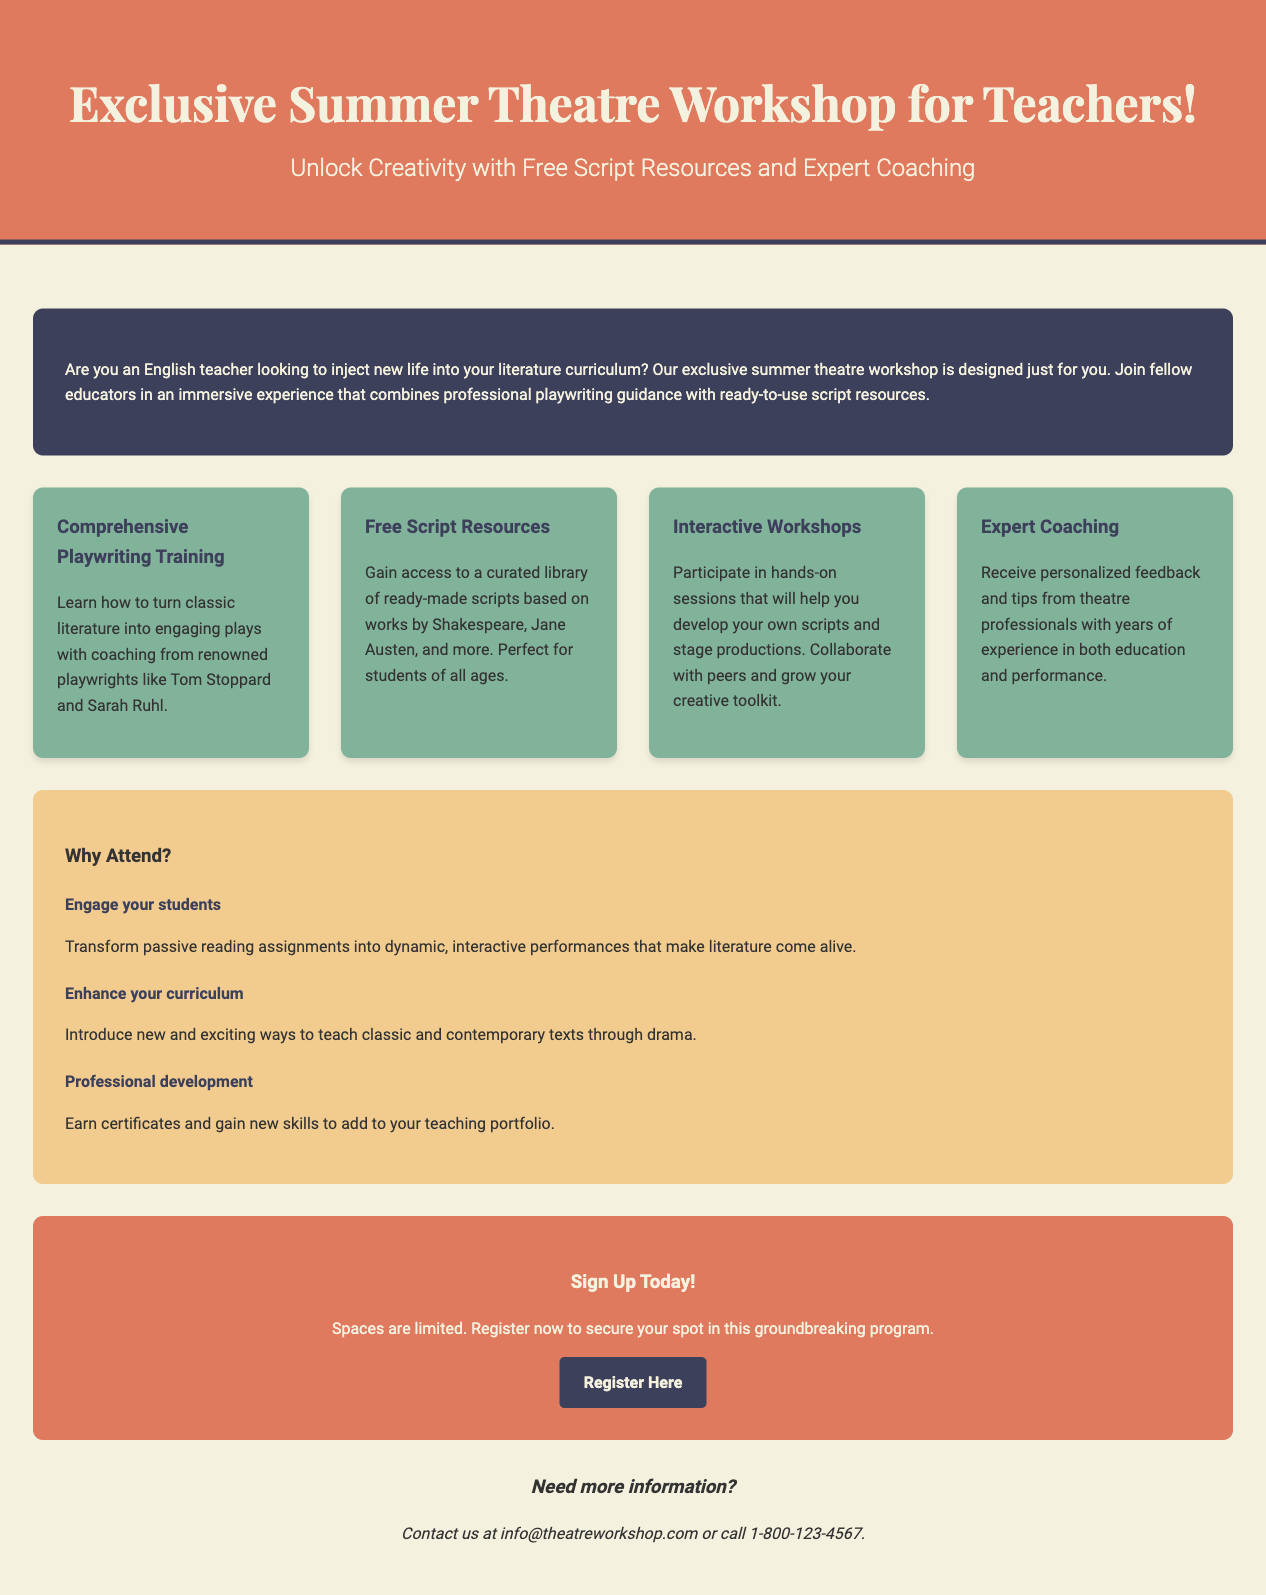What is the title of the workshop? The title of the workshop is clearly stated at the beginning of the document as "Exclusive Summer Theatre Workshop for Teachers!"
Answer: Exclusive Summer Theatre Workshop for Teachers! Who is the target audience for the workshop? The workshop is designed specifically for English teachers, as mentioned in the introduction.
Answer: English teachers What type of training is offered in the workshop? The document specifies that "Comprehensive Playwriting Training" is a feature of the workshop.
Answer: Comprehensive Playwriting Training What is one of the key benefits mentioned for attending the workshop? The document lists "Engage your students" as one of the benefits of attending the workshop.
Answer: Engage your students What is the URL to register for the workshop? The registration link provided in the document is "http://example.com/theatreworkshop".
Answer: http://example.com/theatreworkshop How can interested individuals contact the organizers for more information? The contact information in the document states to email at info@theatreworkshop.com or call a specific number.
Answer: info@theatreworkshop.com or call 1-800-123-4567 What is one of the interactive features of the workshop? The document mentions "Interactive Workshops" as a feature where participants will develop their own scripts.
Answer: Interactive Workshops Who are some of the renowned playwrights mentioned for coaching? The document highlights Tom Stoppard and Sarah Ruhl as renowned playwrights involved in coaching.
Answer: Tom Stoppard and Sarah Ruhl 